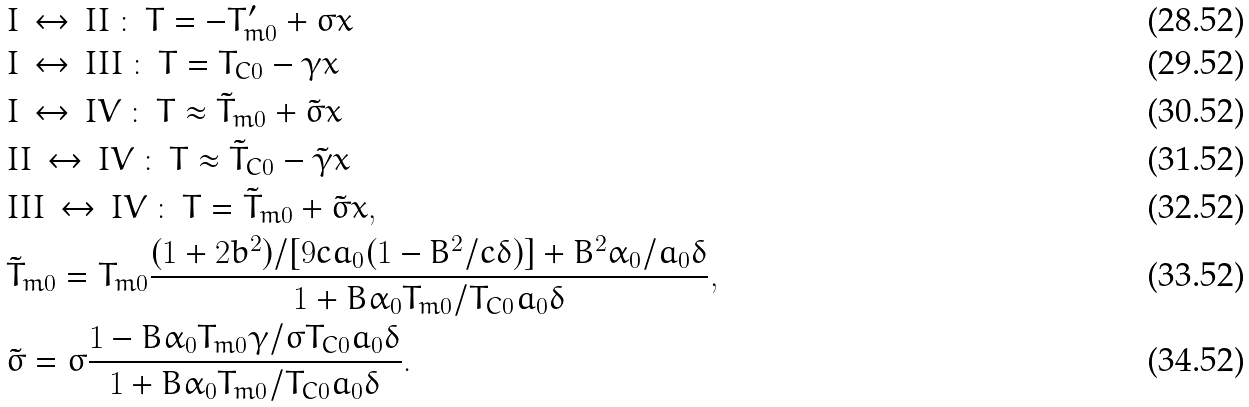Convert formula to latex. <formula><loc_0><loc_0><loc_500><loc_500>& I \, \leftrightarrow \, I I \, \colon \, T = - T _ { m 0 } ^ { \prime } + \sigma x \\ & I \, \leftrightarrow \, I I I \, \colon \, T = T _ { C 0 } - \gamma x \\ & I \, \leftrightarrow \, I V \, \colon \, T \approx \tilde { T } _ { m 0 } + \tilde { \sigma } x \\ & I I \, \leftrightarrow \, I V \, \colon \, T \approx \tilde { T } _ { C 0 } - \tilde { \gamma } x \\ & I I I \, \leftrightarrow \, I V \, \colon \, T = \tilde { T } _ { m 0 } + \tilde { \sigma } x , \\ & \tilde { T } _ { m 0 } = T _ { m 0 } \frac { ( 1 + 2 b ^ { 2 } ) / [ 9 c a _ { 0 } ( 1 - B ^ { 2 } / c \delta ) ] + B ^ { 2 } \alpha _ { 0 } / a _ { 0 } \delta } { 1 + B \alpha _ { 0 } T _ { m 0 } / T _ { C 0 } a _ { 0 } \delta } , \\ & \tilde { \sigma } = \sigma \frac { 1 - B \alpha _ { 0 } T _ { m 0 } \gamma / \sigma T _ { C 0 } a _ { 0 } \delta } { 1 + B \alpha _ { 0 } T _ { m 0 } / T _ { C 0 } a _ { 0 } \delta } .</formula> 